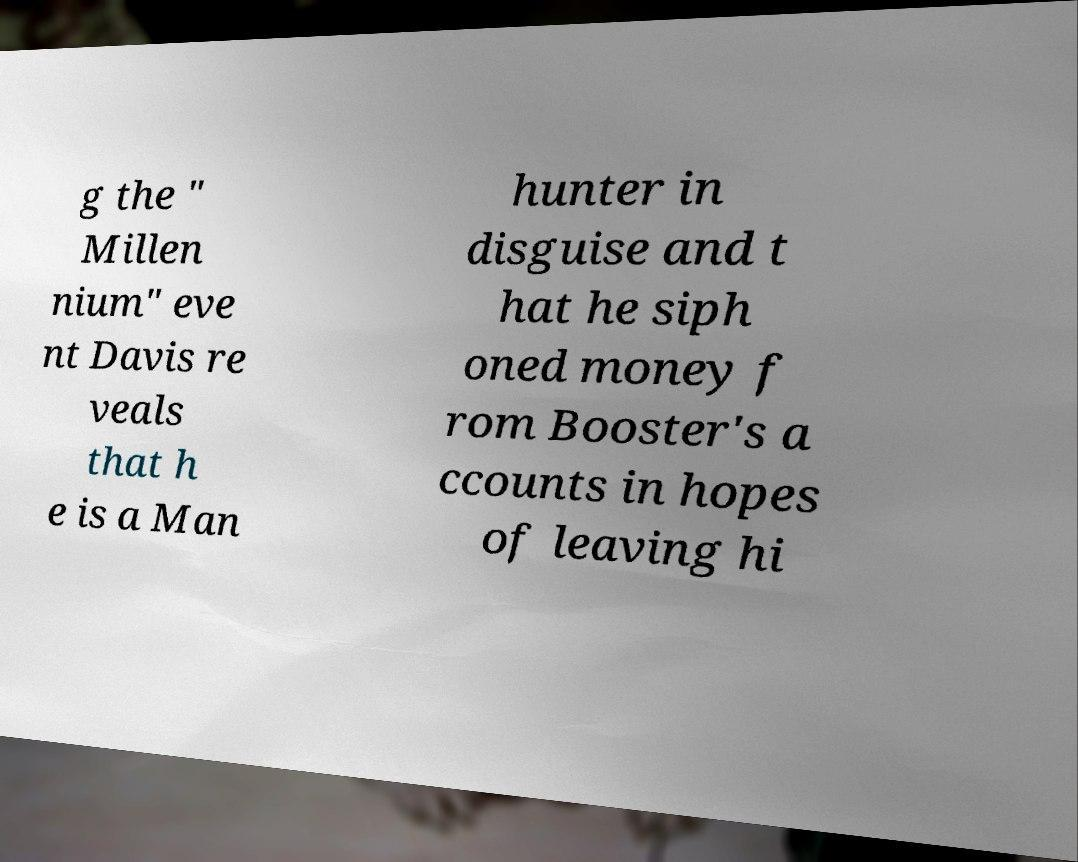Can you accurately transcribe the text from the provided image for me? g the " Millen nium" eve nt Davis re veals that h e is a Man hunter in disguise and t hat he siph oned money f rom Booster's a ccounts in hopes of leaving hi 